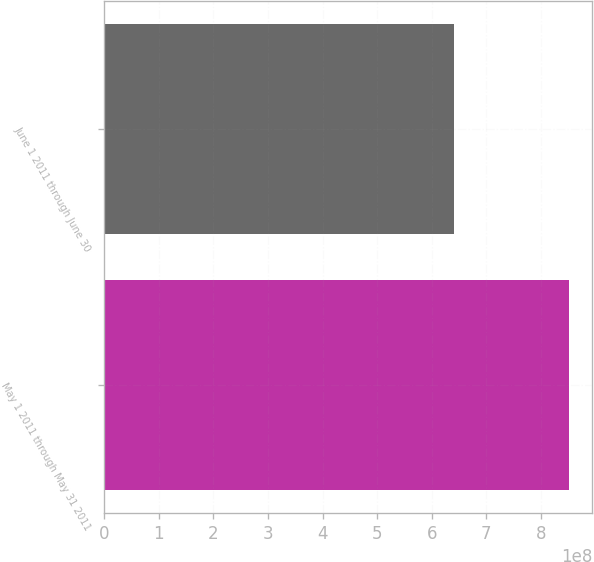Convert chart to OTSL. <chart><loc_0><loc_0><loc_500><loc_500><bar_chart><fcel>May 1 2011 through May 31 2011<fcel>June 1 2011 through June 30<nl><fcel>8.51342e+08<fcel>6.40053e+08<nl></chart> 